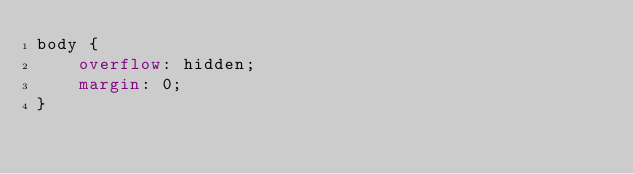Convert code to text. <code><loc_0><loc_0><loc_500><loc_500><_CSS_>body {
    overflow: hidden;
    margin: 0;
}
</code> 